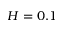<formula> <loc_0><loc_0><loc_500><loc_500>H = 0 . 1</formula> 